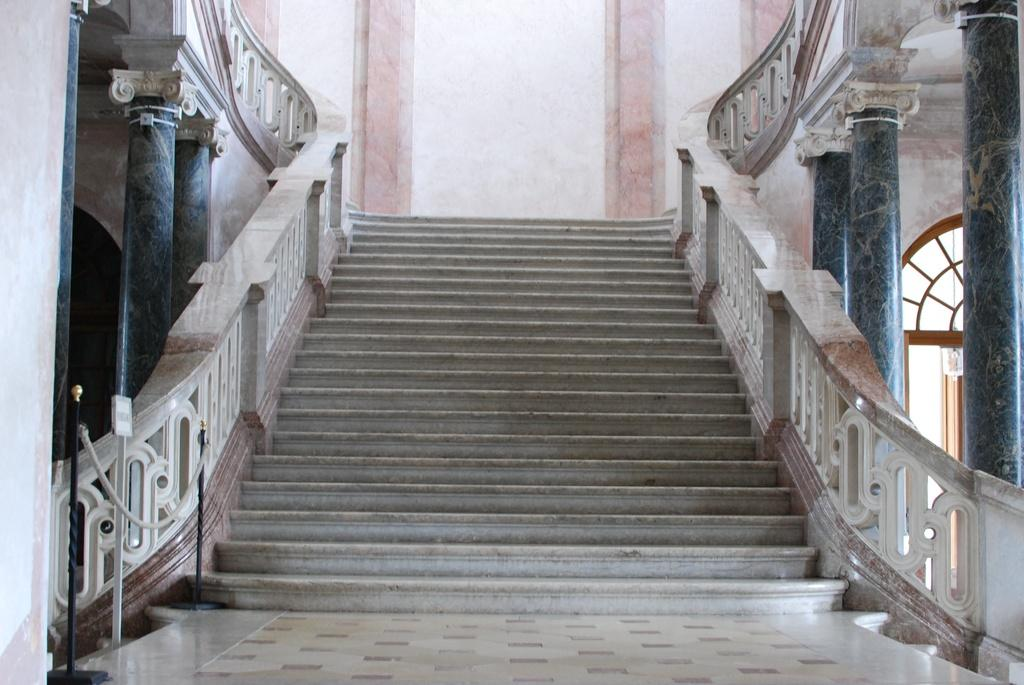What type of architectural feature is present in the image? There are stairs in the image. What safety feature is associated with the stairs? There is a railing associated with the stairs. What other structural elements can be seen in the image? There are pillars in the image. What is visible in the background of the image? There is a wall visible in the background of the image. Can you find the receipt for the house purchase in the image? There is no receipt or house purchase mentioned in the image; it only features stairs, a railing, pillars, and a wall. 